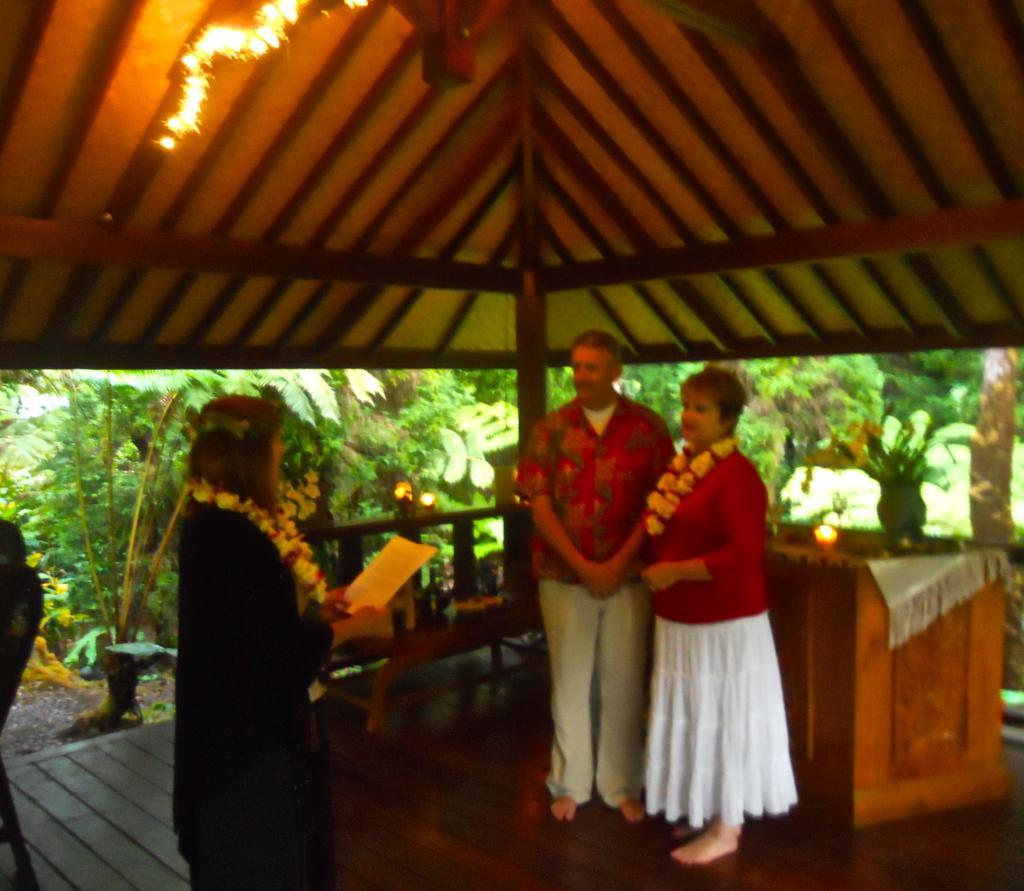Please provide a concise description of this image. A person is standing at the left wearing a garland and holding a paper. 2 people are standing at the right. The person at the right is wearing a red t shirt, white skirt and a garland. There is a table and trees are present at the back. 